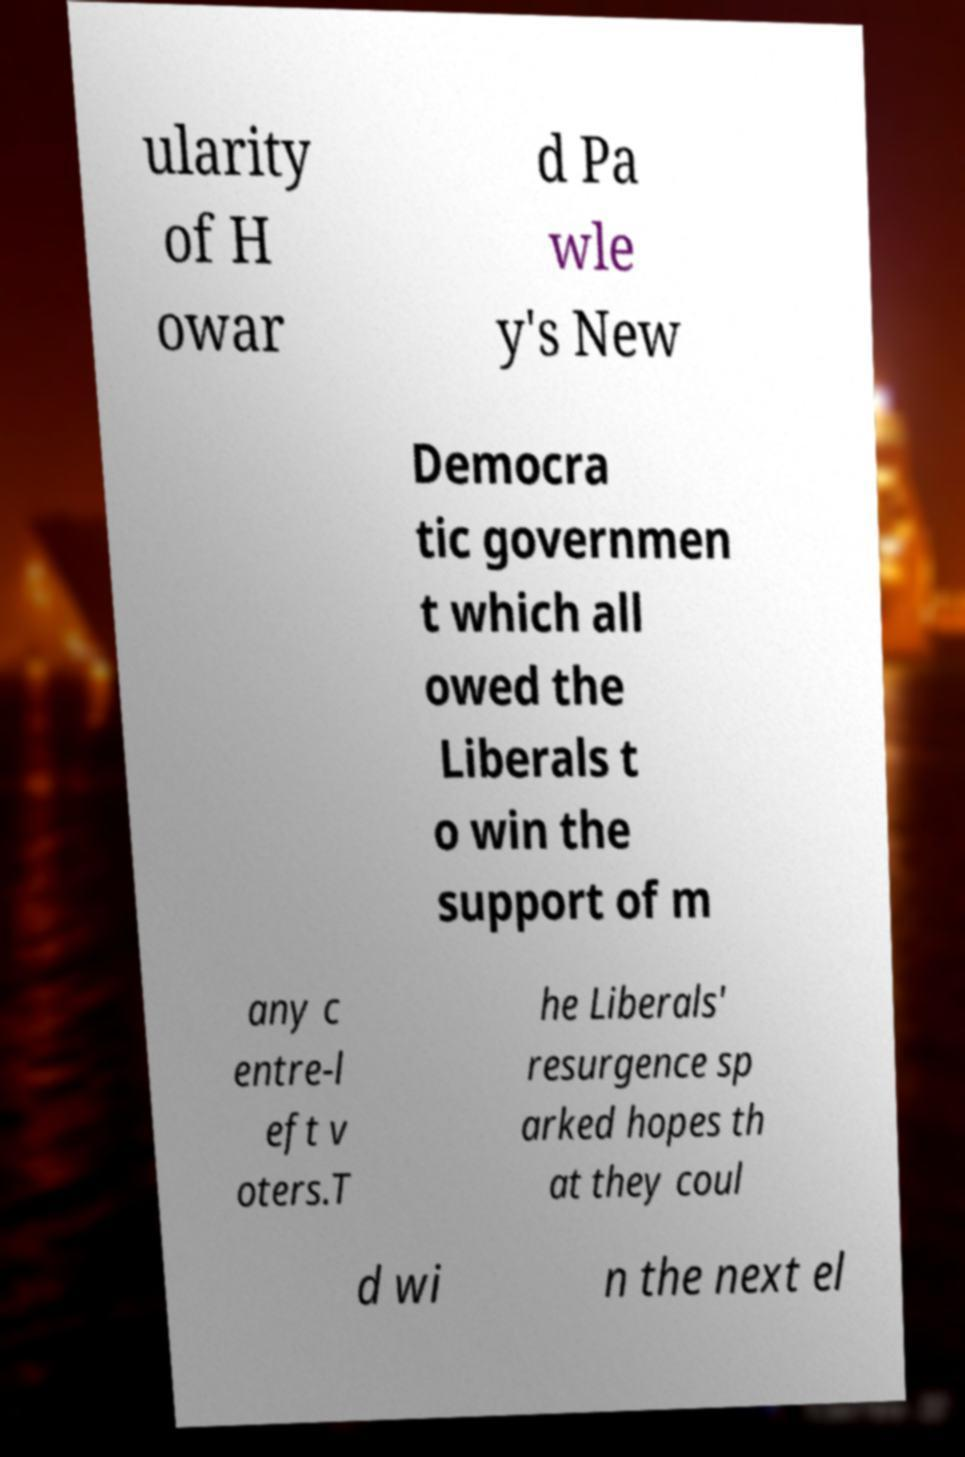Please identify and transcribe the text found in this image. ularity of H owar d Pa wle y's New Democra tic governmen t which all owed the Liberals t o win the support of m any c entre-l eft v oters.T he Liberals' resurgence sp arked hopes th at they coul d wi n the next el 